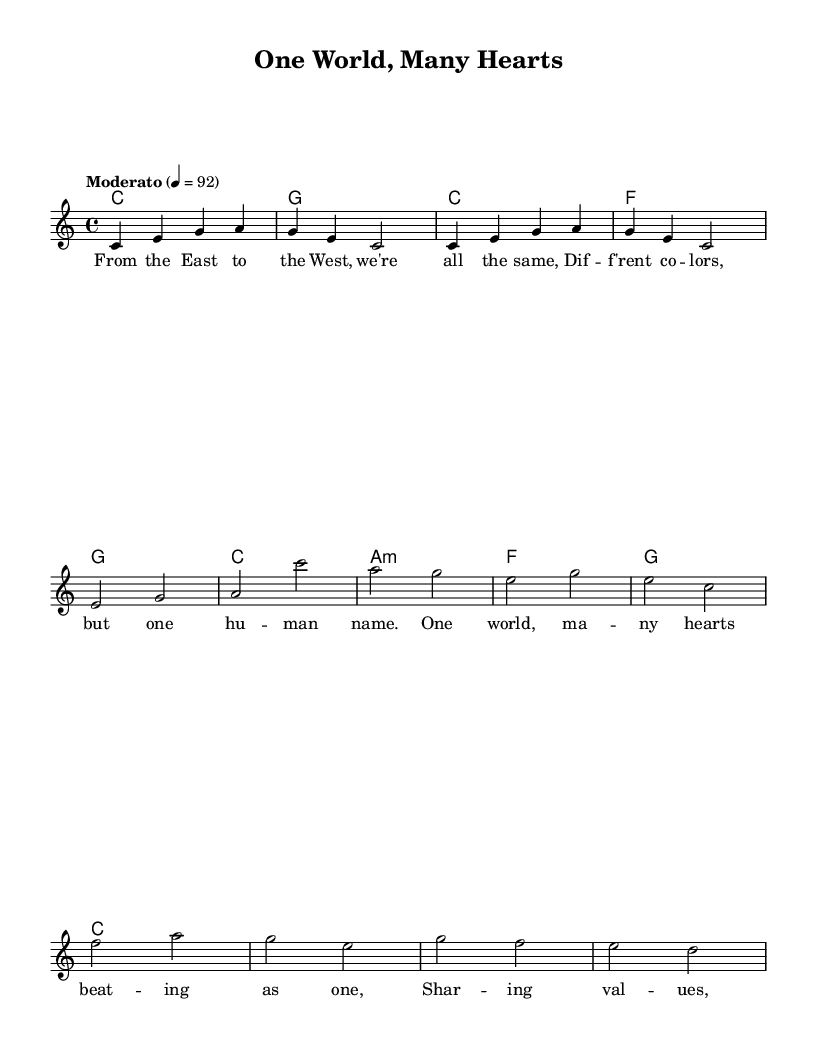What is the key signature of this music? The key signature is indicated at the beginning of the sheet music, and it shows C major as it has no sharps or flats.
Answer: C major What is the time signature of this music? The time signature is displayed at the beginning of the sheet music and indicates that there are four beats in each measure.
Answer: 4/4 What is the tempo marking for this music? The tempo marking is located near the beginning, stating "Moderato," which typically means a moderate speed. The exact beats per minute are also indicated as 92.
Answer: Moderato How many measures are in the verse section? By examining the notation of the verse, we count each bar within that section. The verse consists of four measures of music.
Answer: 4 What type of harmony is used in the chorus? The harmony in the chorus uses a minor chord on the first harmonic progression, specifically indicated as "a1:m", which denotes an A minor chord.
Answer: Minor Which cultural values are expressed in the lyrics? The lyrics emphasize unity in diversity, mentioning "different colors" but recognizing "one human name," which expresses the cultural value of togetherness despite differences.
Answer: Togetherness What is the theme of this musical piece? The lyrics and the title suggest a theme of global unity and shared values, focusing on how people across different cultures are connected.
Answer: Unity 